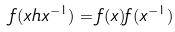Convert formula to latex. <formula><loc_0><loc_0><loc_500><loc_500>f ( x h x ^ { - 1 } ) = f ( x ) f ( x ^ { - 1 } )</formula> 